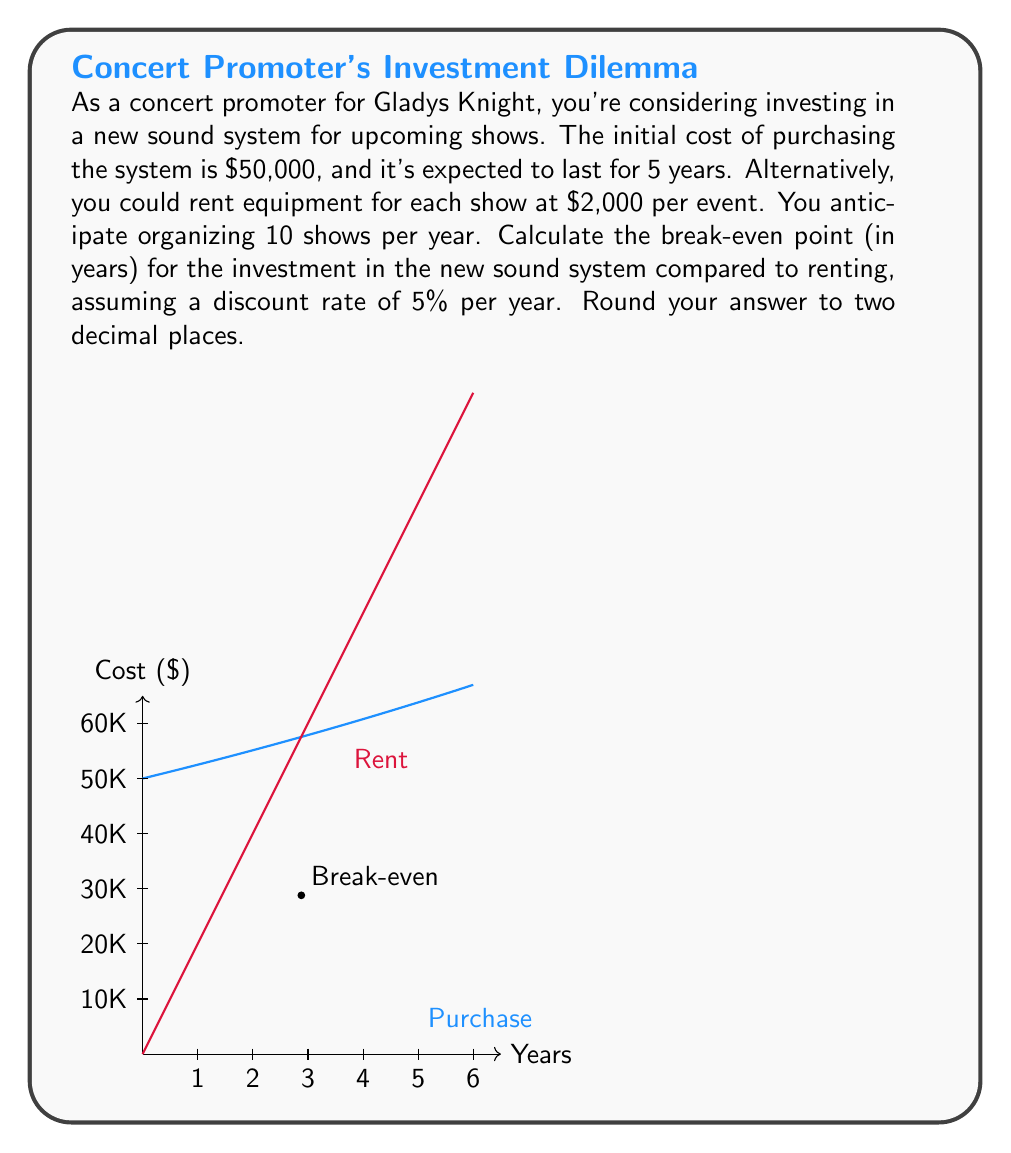Provide a solution to this math problem. Let's approach this step-by-step:

1) First, let's define our variables:
   $P$ = Purchase cost = $50,000
   $R$ = Annual rental cost = $2,000 * 10 = $20,000
   $r$ = Discount rate = 5% = 0.05
   $t$ = Time in years (what we're solving for)

2) The present value of the purchase option after $t$ years is:
   $$PV_{purchase} = P(1+r)^t = 50,000(1.05)^t$$

3) The present value of renting for $t$ years is:
   $$PV_{rent} = R * \frac{1-(1+r)^{-t}}{r} = 20,000 * \frac{1-(1.05)^{-t}}{0.05}$$

4) At the break-even point, these two values are equal:
   $$50,000(1.05)^t = 20,000 * \frac{1-(1.05)^{-t}}{0.05}$$

5) Simplifying:
   $$2.5(1.05)^t = \frac{1-(1.05)^{-t}}{0.05}$$

6) This equation can't be solved algebraically. We need to use numerical methods or a financial calculator. Using such methods, we find:
   $$t ≈ 2.88 \text{ years}$$

7) Rounding to two decimal places, we get 2.88 years.
Answer: 2.88 years 